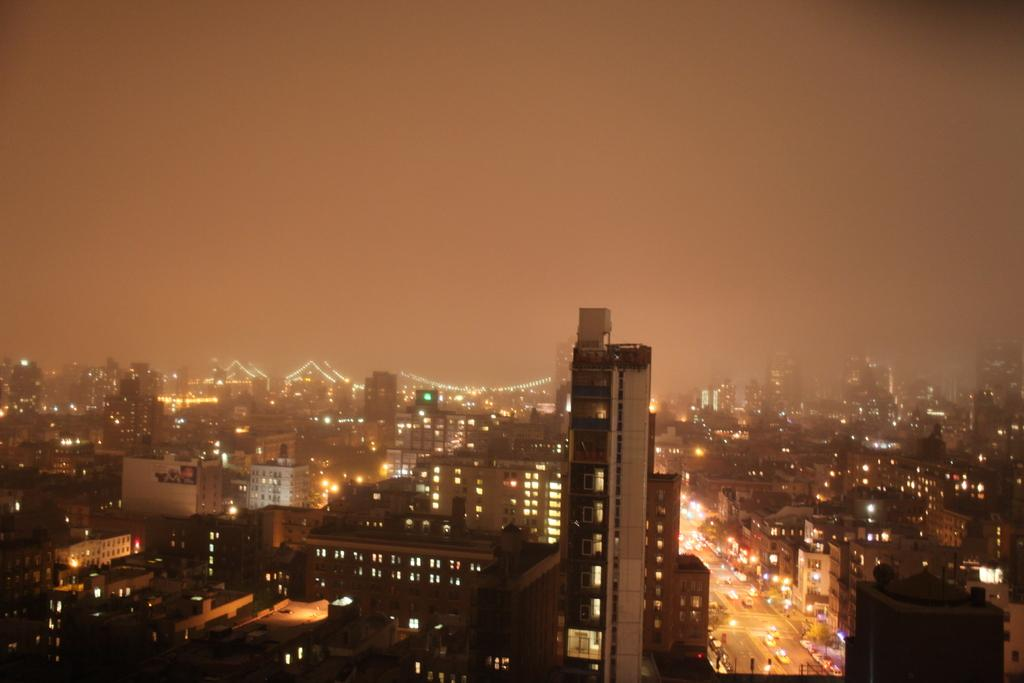What type of structures can be seen in the image? There are buildings in the image. What else is present in the image besides buildings? There are vehicles and lights visible in the image. What type of fork can be seen in the image? There is no fork present in the image. What type of crime is being committed in the image? There is no crime being committed in the image; it features buildings, vehicles, and lights. 